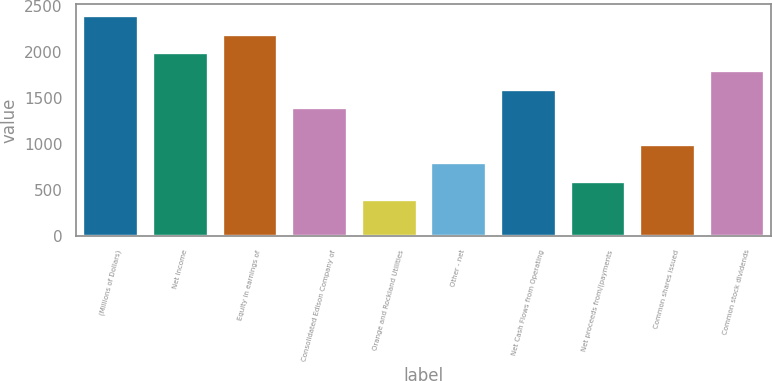Convert chart to OTSL. <chart><loc_0><loc_0><loc_500><loc_500><bar_chart><fcel>(Millions of Dollars)<fcel>Net Income<fcel>Equity in earnings of<fcel>Consolidated Edison Company of<fcel>Orange and Rockland Utilities<fcel>Other - net<fcel>Net Cash Flows from Operating<fcel>Net proceeds from/(payments<fcel>Common shares issued<fcel>Common stock dividends<nl><fcel>2405.6<fcel>2005<fcel>2205.3<fcel>1404.1<fcel>402.6<fcel>803.2<fcel>1604.4<fcel>602.9<fcel>1003.5<fcel>1804.7<nl></chart> 